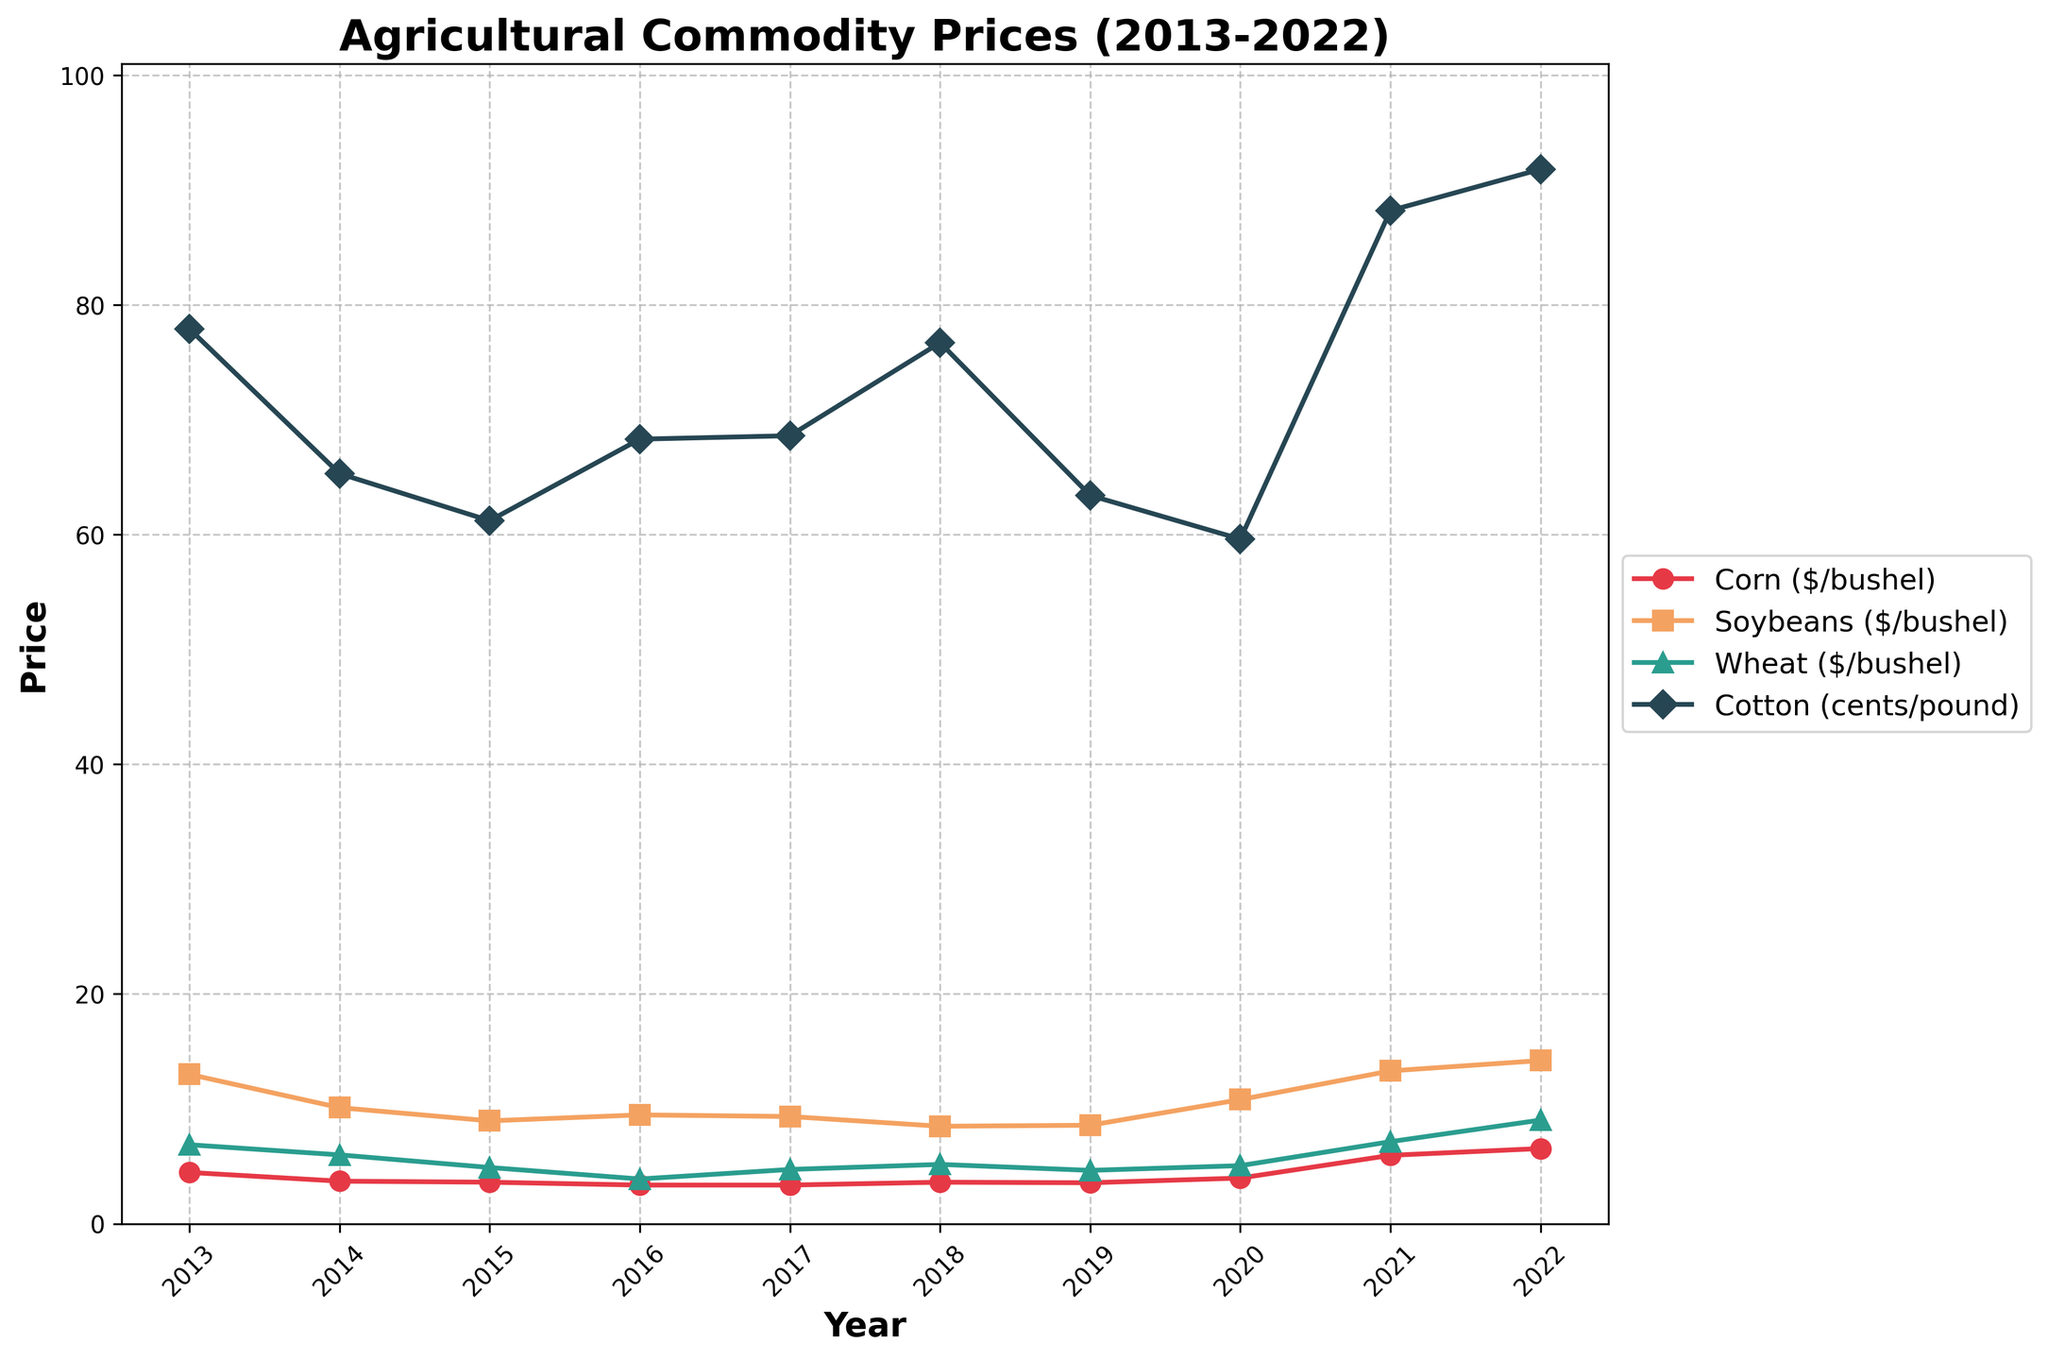What's the highest price reached by any crop in the last decade? To find the highest price, observe the peaks of all the lines. The highest peak is the point for Wheat in 2022 at $9.02 per bushel.
Answer: 9.02 Which crop had the most stable price over the last decade? Define stability by the least amount of fluctuation. Corn's price seems to have the least variation since its line is relatively flat compared to others.
Answer: Corn How did the price of Soybeans change from 2015 to 2020? Look at the Soybeans data points (orange line) in 2015 ($8.95) and 2020 ($10.80), then calculate the difference: $10.80 - $8.95 = $1.85 increase.
Answer: Increased by $1.85 What year did the price of Cotton surpass the 80-cent mark? Check the Cotton line (blue line) and observe where it crosses 80 cents. It happens in 2021.
Answer: 2021 Compare the prices of Corn and Wheat in 2014. Which one was higher, and by how much? Look at the points for Corn ($3.70) and Wheat ($5.99) in 2014. The difference is $5.99 - $3.70 = $2.29. Wheat is higher by $2.29
Answer: Wheat by $2.29 In which years did all crops experience an increase in price compared to the previous year? Compare each line's value year by year and find where all lines go up compared to the previous year. This occurred from 2020 to 2021.
Answer: 2021 Which two crops had the closest prices in 2019? Check the lines at 2019. Corn ($3.56) and Wheat ($4.64) have the smallest difference: $4.64 - $3.56 = $1.08.
Answer: Corn and Wheat What's the average price of Cotton over the decade between 2013 and 2022? Sum the Cotton prices and divide by the number of years: (77.9 + 65.3 + 61.2 + 68.3 + 68.6 + 76.7 + 63.4 + 59.6 + 88.2 + 91.8) / 10 = 72.1 cents per pound.
Answer: 72.1 Between which two consecutive years did Wheat see the highest increase in price? By observing the yearly increases, Wheat had its highest jump from 2021 ($7.14) to 2022 ($9.02), an increase of $1.88.
Answer: 2021 to 2022 